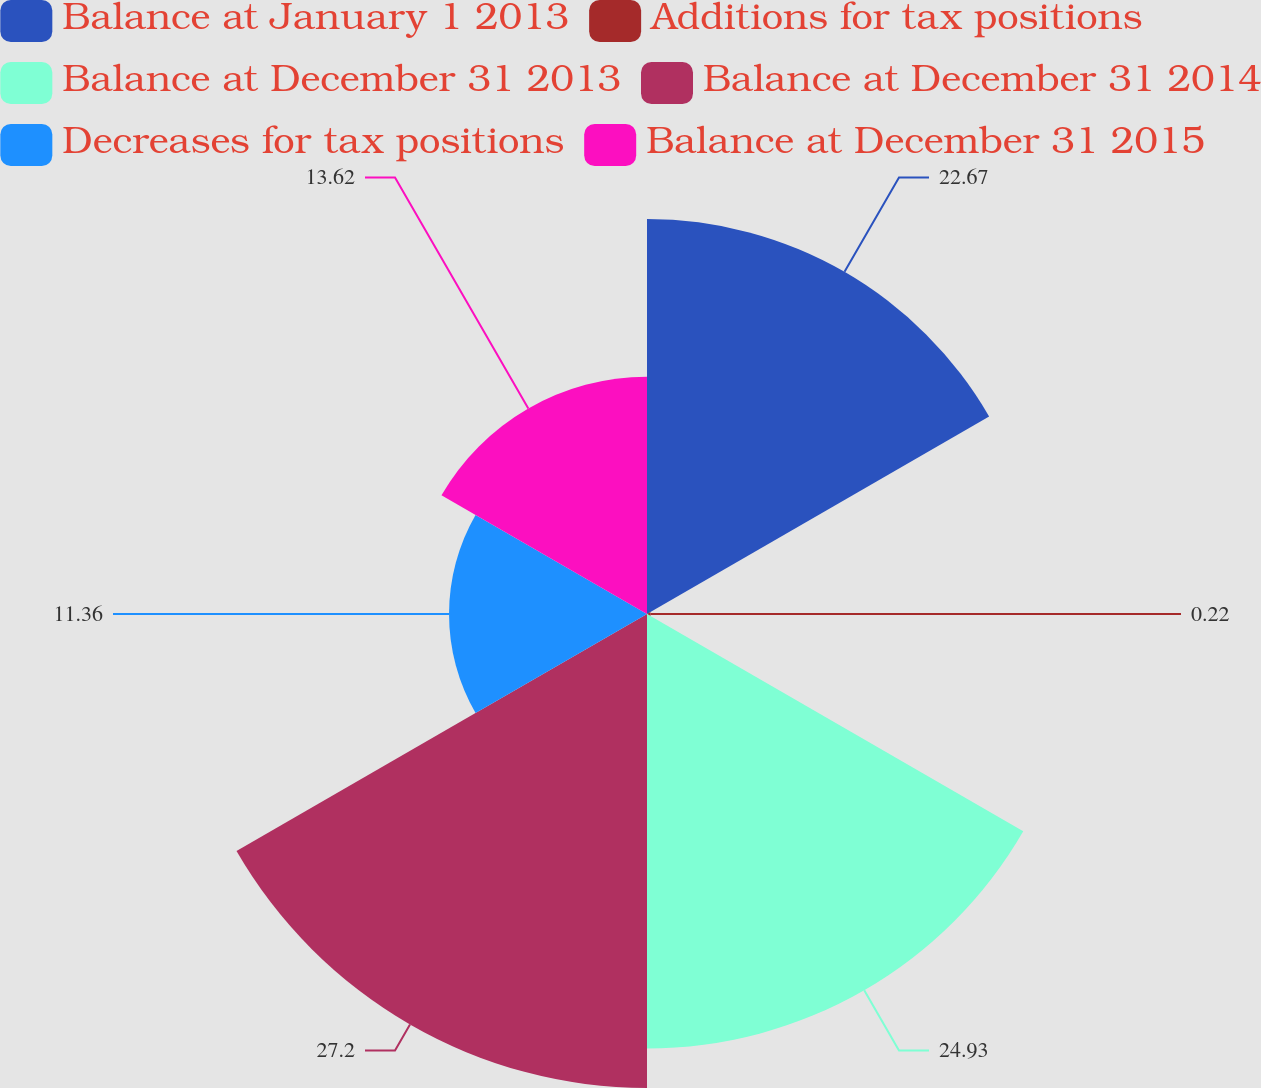Convert chart to OTSL. <chart><loc_0><loc_0><loc_500><loc_500><pie_chart><fcel>Balance at January 1 2013<fcel>Additions for tax positions<fcel>Balance at December 31 2013<fcel>Balance at December 31 2014<fcel>Decreases for tax positions<fcel>Balance at December 31 2015<nl><fcel>22.67%<fcel>0.22%<fcel>24.93%<fcel>27.2%<fcel>11.36%<fcel>13.62%<nl></chart> 